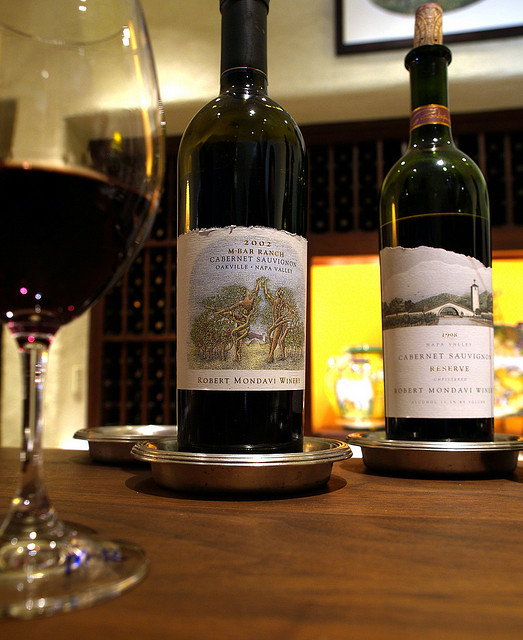<image>What animal is on the wine bottle? I don't know what animal is on the wine bottle. It can be peacock, giraffe, bird, snake, or horse. What animal is on the wine bottle? It is not possible to determine what animal is on the wine bottle. 